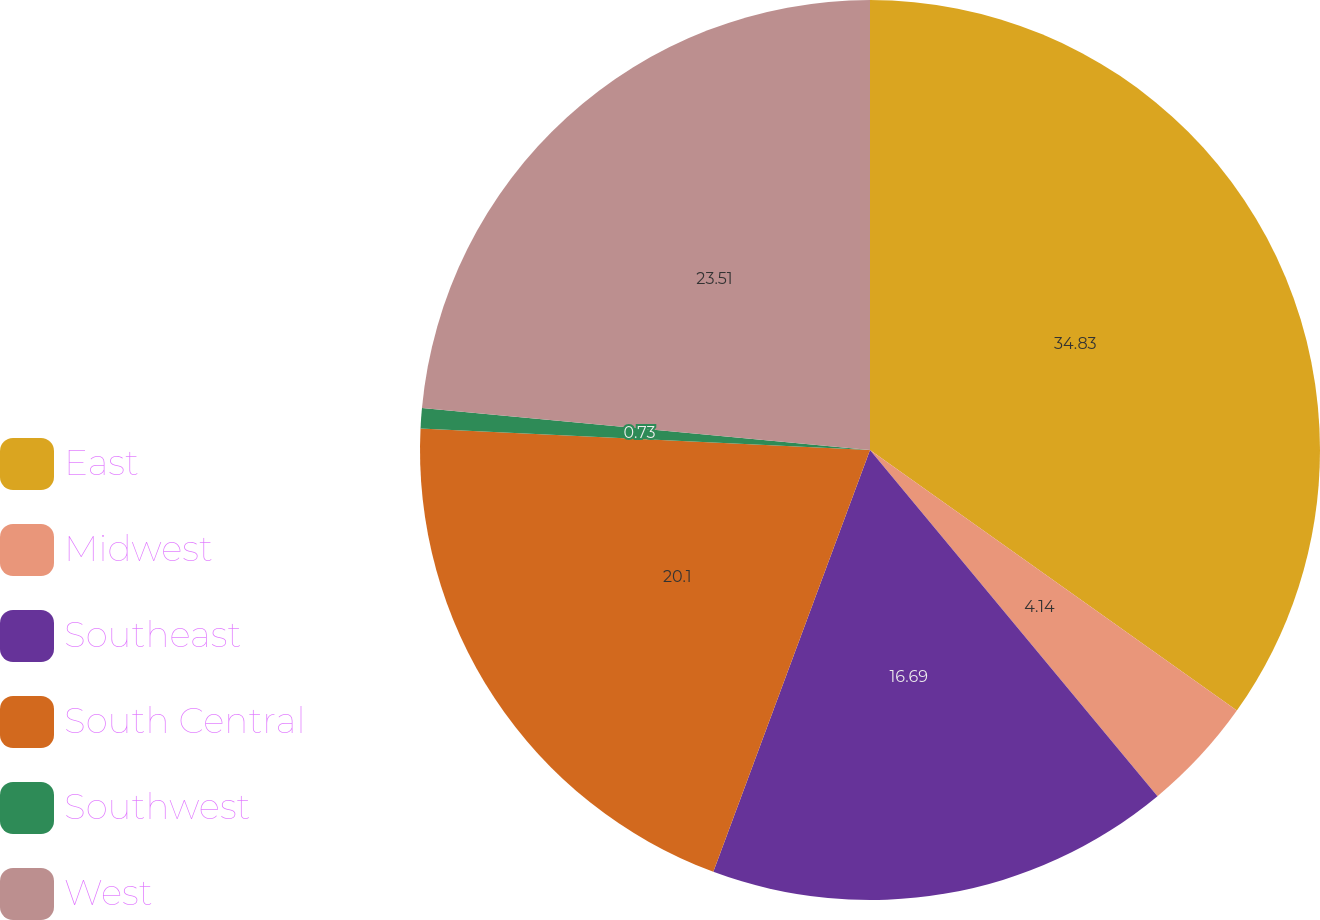Convert chart to OTSL. <chart><loc_0><loc_0><loc_500><loc_500><pie_chart><fcel>East<fcel>Midwest<fcel>Southeast<fcel>South Central<fcel>Southwest<fcel>West<nl><fcel>34.83%<fcel>4.14%<fcel>16.69%<fcel>20.1%<fcel>0.73%<fcel>23.51%<nl></chart> 